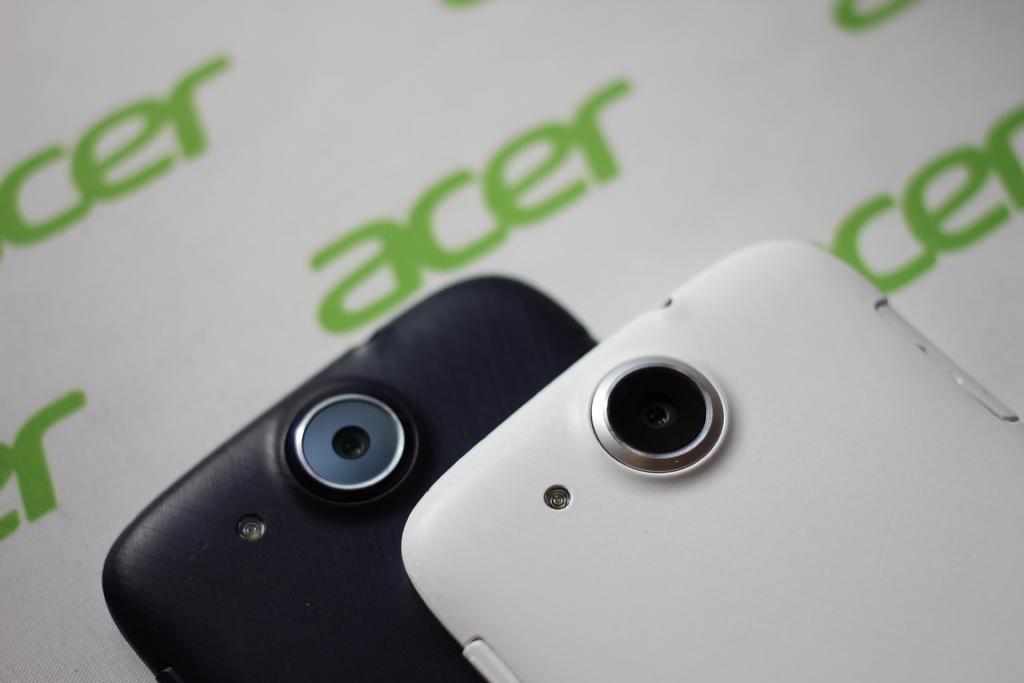How many mobile phones are visible in the image? There are two mobile phones in the image. What type of tooth is being used to work on the mobile phones in the image? There are no teeth present in the image, and mobile phones do not require teeth for any purpose. 